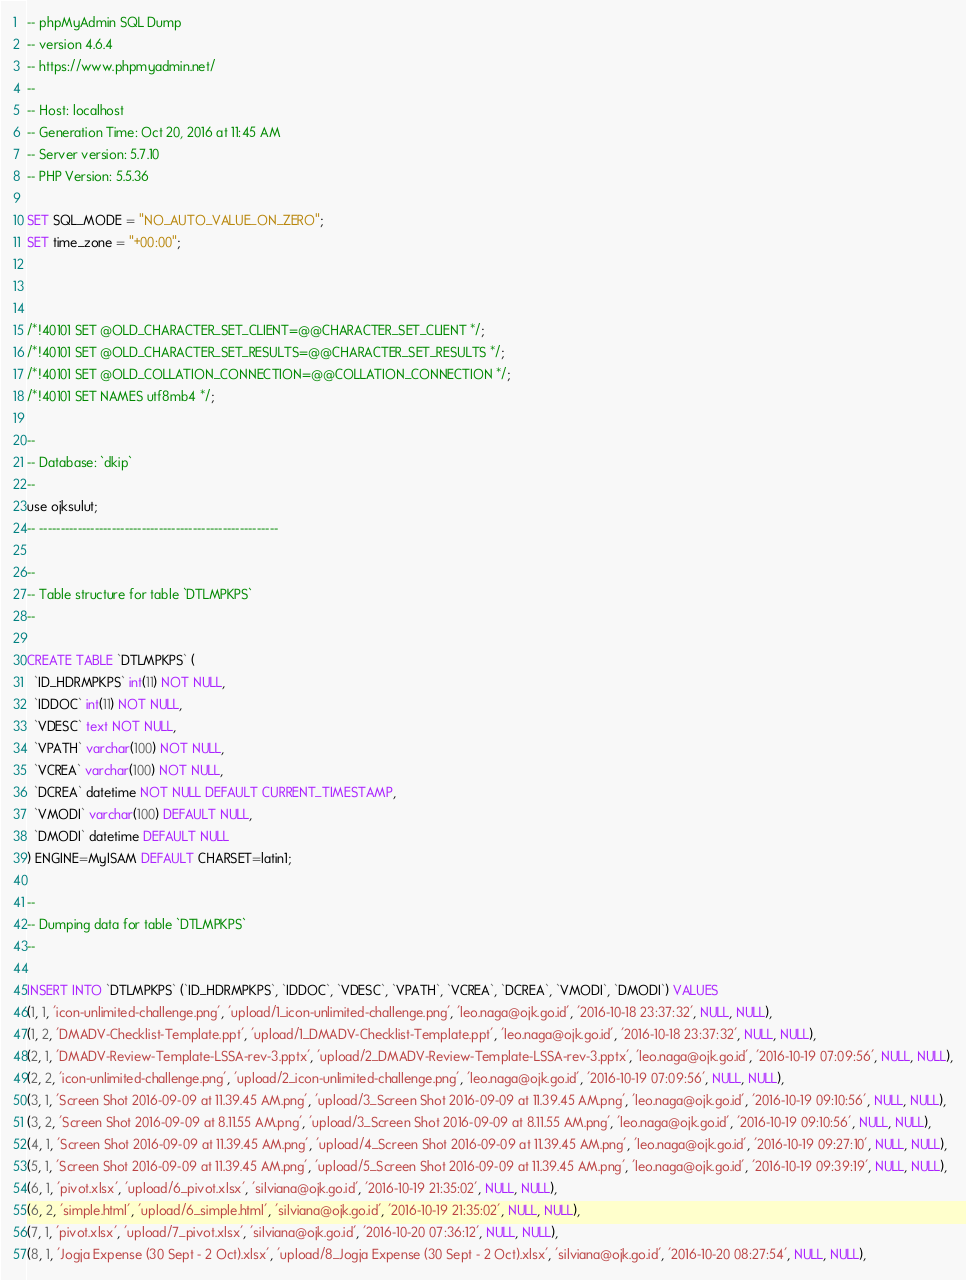<code> <loc_0><loc_0><loc_500><loc_500><_SQL_>-- phpMyAdmin SQL Dump
-- version 4.6.4
-- https://www.phpmyadmin.net/
--
-- Host: localhost
-- Generation Time: Oct 20, 2016 at 11:45 AM
-- Server version: 5.7.10
-- PHP Version: 5.5.36

SET SQL_MODE = "NO_AUTO_VALUE_ON_ZERO";
SET time_zone = "+00:00";



/*!40101 SET @OLD_CHARACTER_SET_CLIENT=@@CHARACTER_SET_CLIENT */;
/*!40101 SET @OLD_CHARACTER_SET_RESULTS=@@CHARACTER_SET_RESULTS */;
/*!40101 SET @OLD_COLLATION_CONNECTION=@@COLLATION_CONNECTION */;
/*!40101 SET NAMES utf8mb4 */;

--
-- Database: `dkip`
--
use ojksulut;
-- --------------------------------------------------------

--
-- Table structure for table `DTLMPKPS`
--

CREATE TABLE `DTLMPKPS` (
  `ID_HDRMPKPS` int(11) NOT NULL,
  `IDDOC` int(11) NOT NULL,
  `VDESC` text NOT NULL,
  `VPATH` varchar(100) NOT NULL,
  `VCREA` varchar(100) NOT NULL,
  `DCREA` datetime NOT NULL DEFAULT CURRENT_TIMESTAMP,
  `VMODI` varchar(100) DEFAULT NULL,
  `DMODI` datetime DEFAULT NULL
) ENGINE=MyISAM DEFAULT CHARSET=latin1;

--
-- Dumping data for table `DTLMPKPS`
--

INSERT INTO `DTLMPKPS` (`ID_HDRMPKPS`, `IDDOC`, `VDESC`, `VPATH`, `VCREA`, `DCREA`, `VMODI`, `DMODI`) VALUES
(1, 1, 'icon-unlimited-challenge.png', 'upload/1_icon-unlimited-challenge.png', 'leo.naga@ojk.go.id', '2016-10-18 23:37:32', NULL, NULL),
(1, 2, 'DMADV-Checklist-Template.ppt', 'upload/1_DMADV-Checklist-Template.ppt', 'leo.naga@ojk.go.id', '2016-10-18 23:37:32', NULL, NULL),
(2, 1, 'DMADV-Review-Template-LSSA-rev-3.pptx', 'upload/2_DMADV-Review-Template-LSSA-rev-3.pptx', 'leo.naga@ojk.go.id', '2016-10-19 07:09:56', NULL, NULL),
(2, 2, 'icon-unlimited-challenge.png', 'upload/2_icon-unlimited-challenge.png', 'leo.naga@ojk.go.id', '2016-10-19 07:09:56', NULL, NULL),
(3, 1, 'Screen Shot 2016-09-09 at 11.39.45 AM.png', 'upload/3_Screen Shot 2016-09-09 at 11.39.45 AM.png', 'leo.naga@ojk.go.id', '2016-10-19 09:10:56', NULL, NULL),
(3, 2, 'Screen Shot 2016-09-09 at 8.11.55 AM.png', 'upload/3_Screen Shot 2016-09-09 at 8.11.55 AM.png', 'leo.naga@ojk.go.id', '2016-10-19 09:10:56', NULL, NULL),
(4, 1, 'Screen Shot 2016-09-09 at 11.39.45 AM.png', 'upload/4_Screen Shot 2016-09-09 at 11.39.45 AM.png', 'leo.naga@ojk.go.id', '2016-10-19 09:27:10', NULL, NULL),
(5, 1, 'Screen Shot 2016-09-09 at 11.39.45 AM.png', 'upload/5_Screen Shot 2016-09-09 at 11.39.45 AM.png', 'leo.naga@ojk.go.id', '2016-10-19 09:39:19', NULL, NULL),
(6, 1, 'pivot.xlsx', 'upload/6_pivot.xlsx', 'silviana@ojk.go.id', '2016-10-19 21:35:02', NULL, NULL),
(6, 2, 'simple.html', 'upload/6_simple.html', 'silviana@ojk.go.id', '2016-10-19 21:35:02', NULL, NULL),
(7, 1, 'pivot.xlsx', 'upload/7_pivot.xlsx', 'silviana@ojk.go.id', '2016-10-20 07:36:12', NULL, NULL),
(8, 1, 'Jogja Expense (30 Sept - 2 Oct).xlsx', 'upload/8_Jogja Expense (30 Sept - 2 Oct).xlsx', 'silviana@ojk.go.id', '2016-10-20 08:27:54', NULL, NULL),</code> 